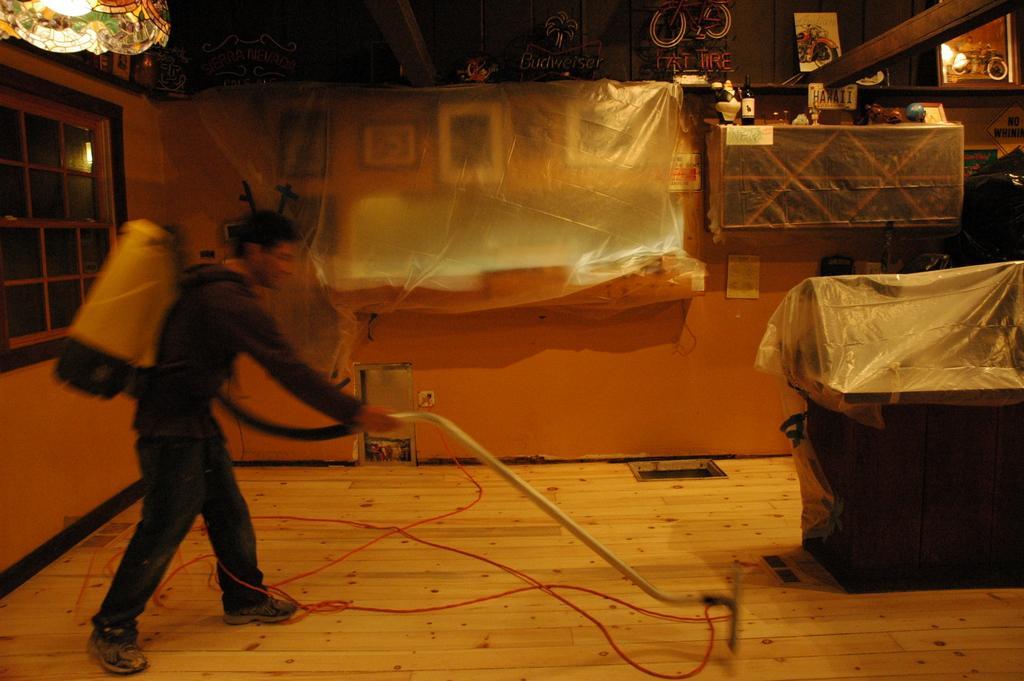Can you describe this image briefly? In this picture I can see a human cleaning with the help of vacuum cleaner and I can see few covers on the items. 